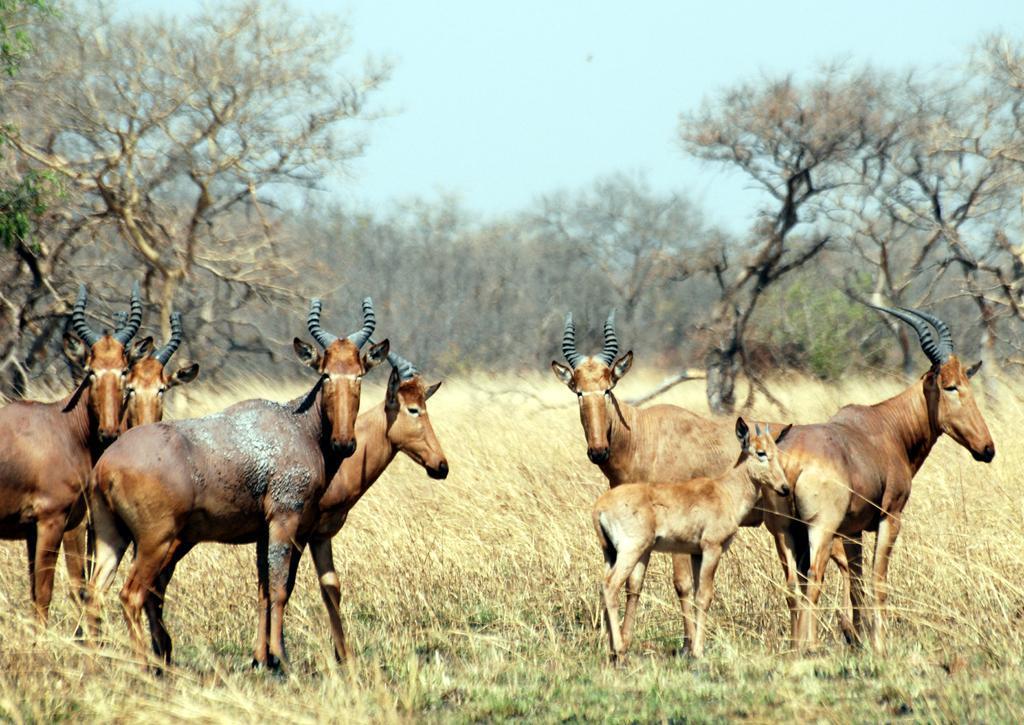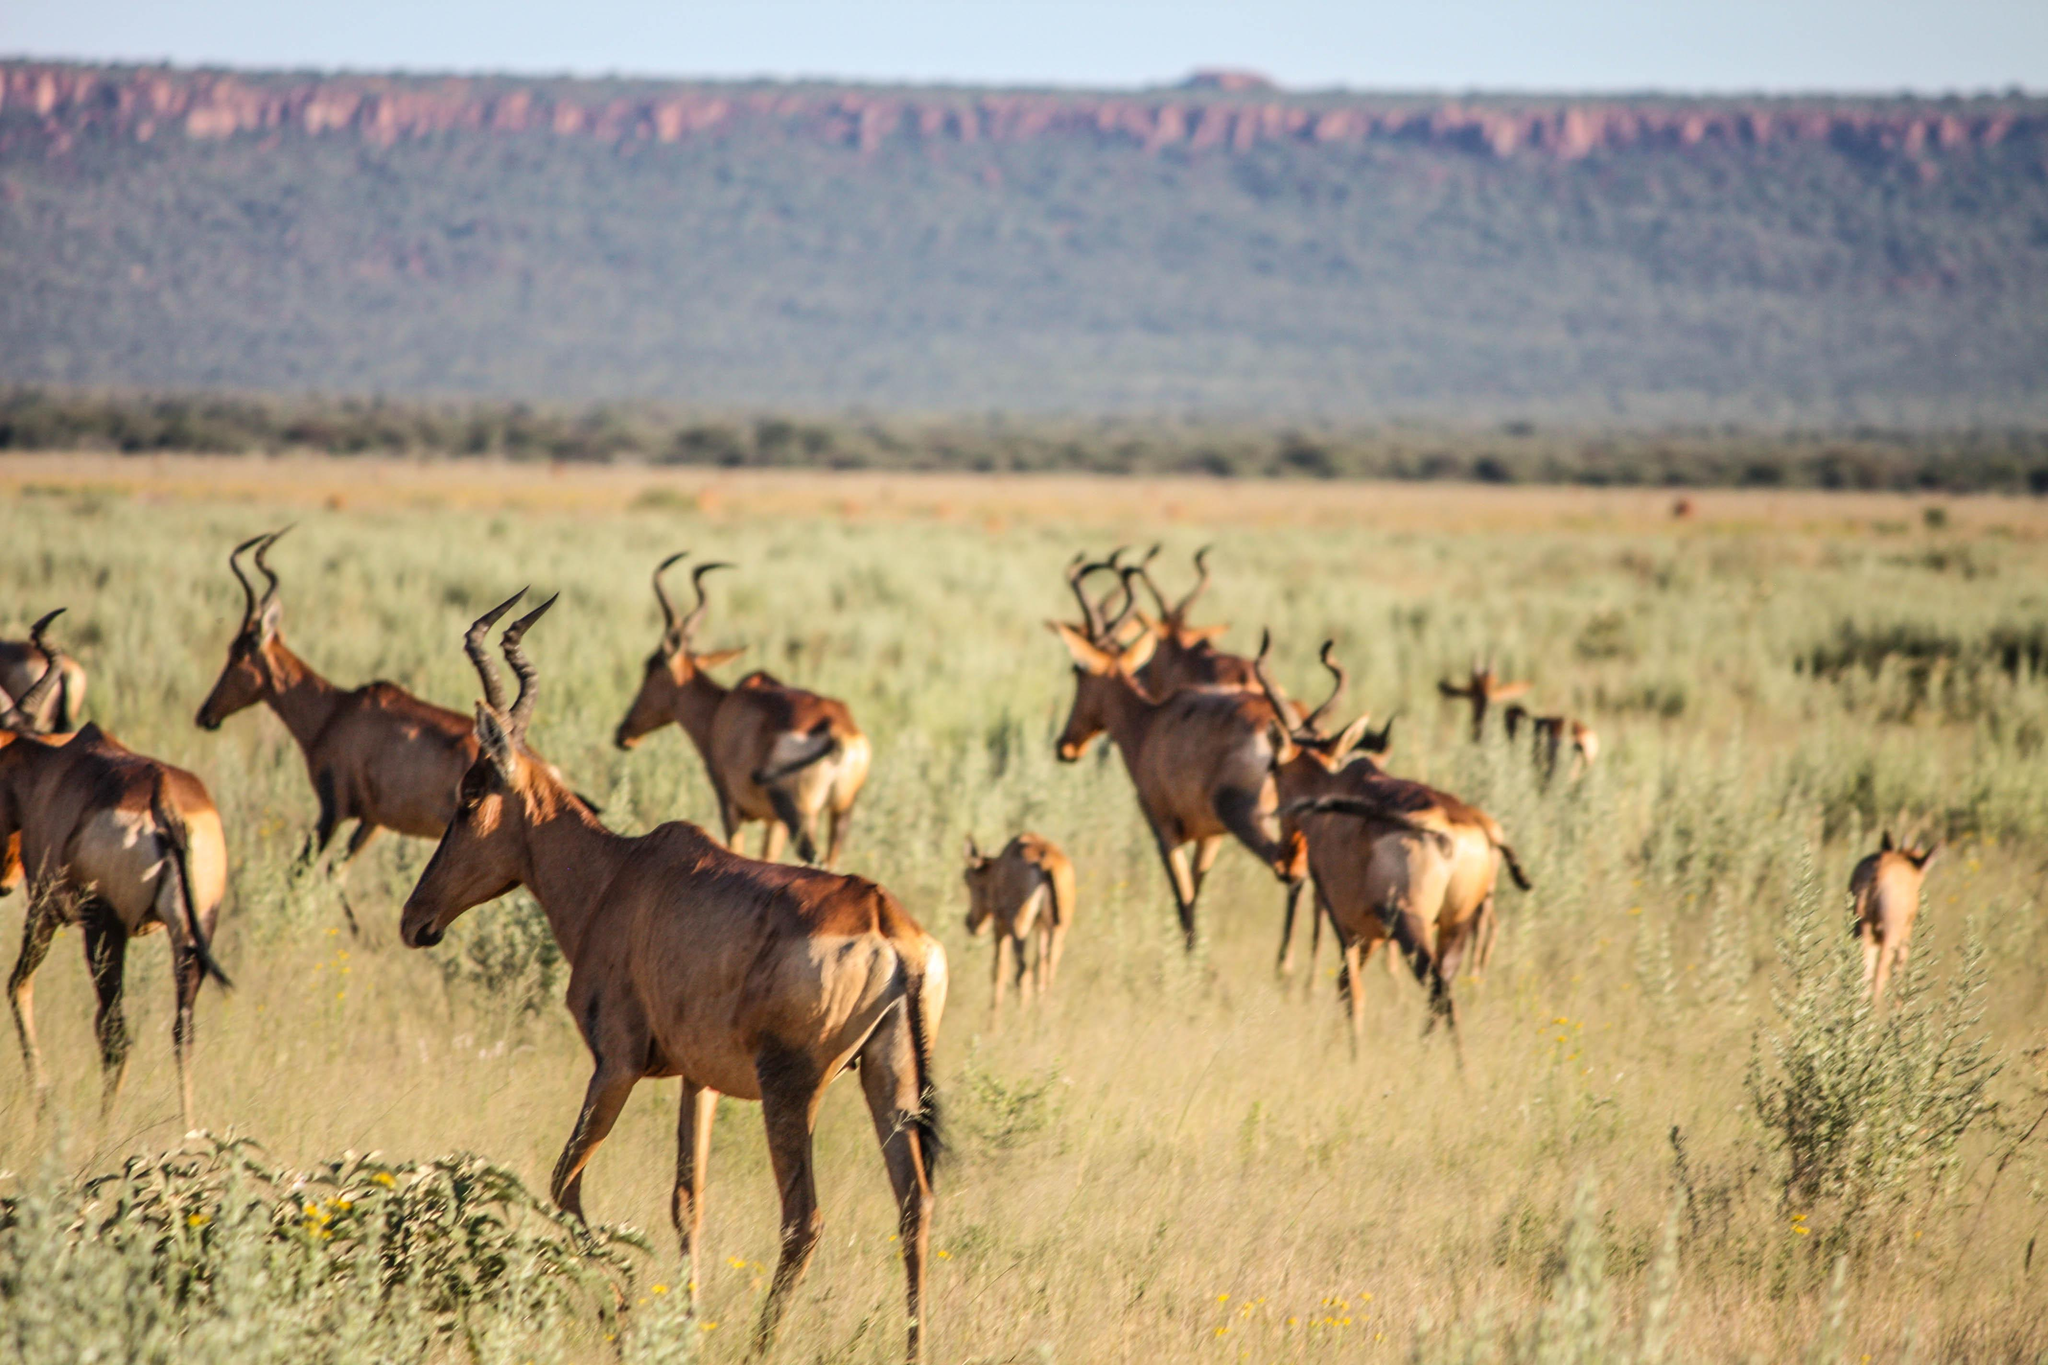The first image is the image on the left, the second image is the image on the right. Assess this claim about the two images: "The right photo contains two kinds of animals.". Correct or not? Answer yes or no. No. The first image is the image on the left, the second image is the image on the right. Considering the images on both sides, is "Zebra are present in a field with horned animals in one image." valid? Answer yes or no. No. 